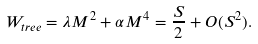Convert formula to latex. <formula><loc_0><loc_0><loc_500><loc_500>W _ { t r e e } = \lambda M ^ { 2 } + \alpha M ^ { 4 } = \frac { S } { 2 } + O ( S ^ { 2 } ) .</formula> 